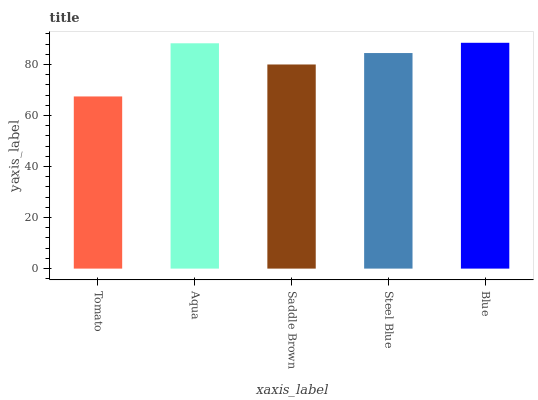Is Tomato the minimum?
Answer yes or no. Yes. Is Blue the maximum?
Answer yes or no. Yes. Is Aqua the minimum?
Answer yes or no. No. Is Aqua the maximum?
Answer yes or no. No. Is Aqua greater than Tomato?
Answer yes or no. Yes. Is Tomato less than Aqua?
Answer yes or no. Yes. Is Tomato greater than Aqua?
Answer yes or no. No. Is Aqua less than Tomato?
Answer yes or no. No. Is Steel Blue the high median?
Answer yes or no. Yes. Is Steel Blue the low median?
Answer yes or no. Yes. Is Saddle Brown the high median?
Answer yes or no. No. Is Blue the low median?
Answer yes or no. No. 